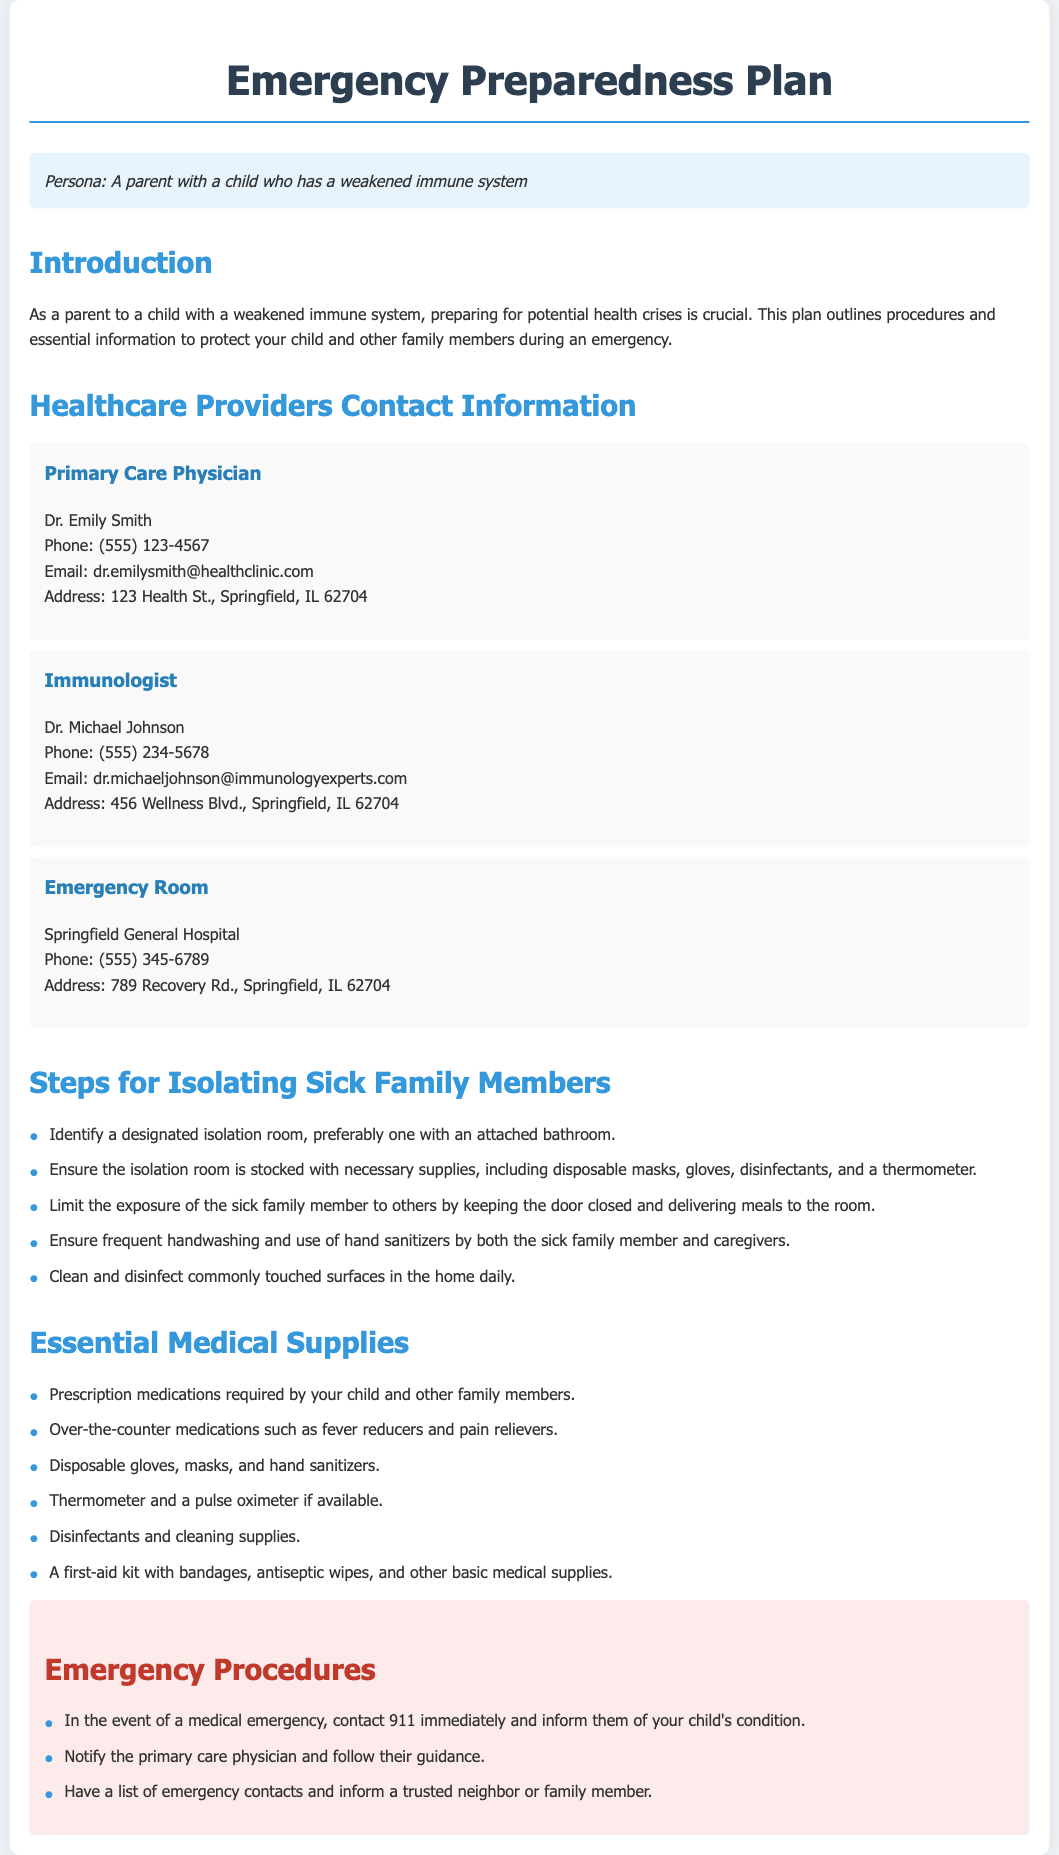What is the name of the primary care physician? The document states that the primary care physician is Dr. Emily Smith.
Answer: Dr. Emily Smith What is the phone number for the immunologist? The phone number provided for the immunologist, Dr. Michael Johnson, is (555) 234-5678.
Answer: (555) 234-5678 What is one step suggested for isolating sick family members? The document lists steps for isolating sick family members, one of which is to "Identify a designated isolation room."
Answer: Identify a designated isolation room What is one essential medical supply mentioned? The document outlines essential medical supplies, including prescription medications required by your child and other family members.
Answer: Prescription medications What should you do in a medical emergency? The document specifies that one should "contact 911 immediately" in the event of a medical emergency.
Answer: Contact 911 immediately What color is used for the section headings in the document? The section headings, such as "Healthcare Providers Contact Information," use the color #3498db.
Answer: #3498db How many healthcare providers are listed in the document? The document lists three healthcare providers: a primary care physician, an immunologist, and an emergency room.
Answer: Three What type of plan is outlined in the document? The document outlines an "Emergency Preparedness Plan."
Answer: Emergency Preparedness Plan 